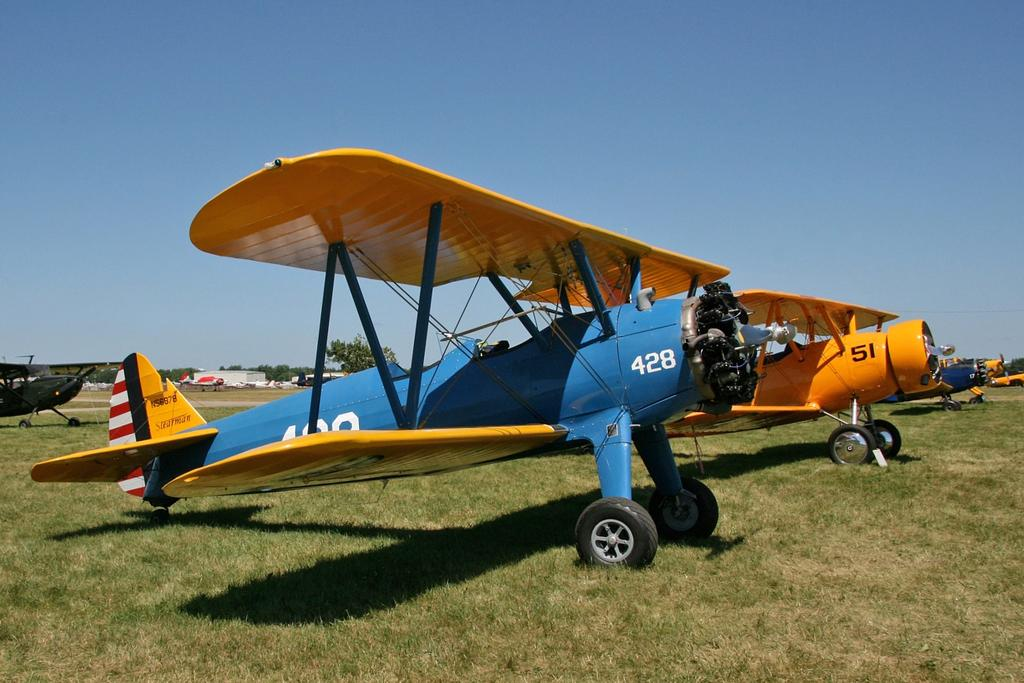What is the main subject of the image? The main subject of the image is aircrafts. What is the current state of the aircrafts in the image? The aircrafts are parked. What type of natural environment is visible in the image? There is grass visible in the image, and there is a tree as well. What can be seen in the background of the image? There is a building in the background of the image. What is visible above the aircrafts and the surrounding environment? The sky is visible in the image. How does the image compare to a love story? The image does not depict a love story; it features parked aircrafts, grass, a tree, a building, and the sky. What type of trouble can be seen in the image? There is no trouble depicted in the image; it is a scene of parked aircrafts, grass, a tree, a building, and the sky. 